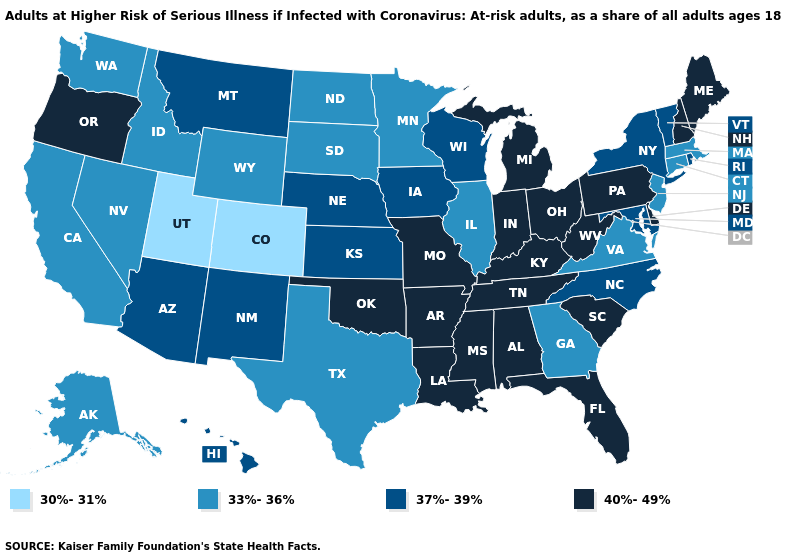Name the states that have a value in the range 33%-36%?
Give a very brief answer. Alaska, California, Connecticut, Georgia, Idaho, Illinois, Massachusetts, Minnesota, Nevada, New Jersey, North Dakota, South Dakota, Texas, Virginia, Washington, Wyoming. What is the value of New Mexico?
Quick response, please. 37%-39%. Name the states that have a value in the range 30%-31%?
Quick response, please. Colorado, Utah. What is the value of Nevada?
Write a very short answer. 33%-36%. What is the value of Vermont?
Quick response, please. 37%-39%. How many symbols are there in the legend?
Quick response, please. 4. Which states have the lowest value in the USA?
Answer briefly. Colorado, Utah. Name the states that have a value in the range 30%-31%?
Write a very short answer. Colorado, Utah. What is the lowest value in states that border Missouri?
Be succinct. 33%-36%. Name the states that have a value in the range 40%-49%?
Give a very brief answer. Alabama, Arkansas, Delaware, Florida, Indiana, Kentucky, Louisiana, Maine, Michigan, Mississippi, Missouri, New Hampshire, Ohio, Oklahoma, Oregon, Pennsylvania, South Carolina, Tennessee, West Virginia. Does Wisconsin have the highest value in the MidWest?
Answer briefly. No. Name the states that have a value in the range 37%-39%?
Give a very brief answer. Arizona, Hawaii, Iowa, Kansas, Maryland, Montana, Nebraska, New Mexico, New York, North Carolina, Rhode Island, Vermont, Wisconsin. Name the states that have a value in the range 37%-39%?
Give a very brief answer. Arizona, Hawaii, Iowa, Kansas, Maryland, Montana, Nebraska, New Mexico, New York, North Carolina, Rhode Island, Vermont, Wisconsin. Does Texas have the same value as Kentucky?
Be succinct. No. Name the states that have a value in the range 30%-31%?
Quick response, please. Colorado, Utah. 